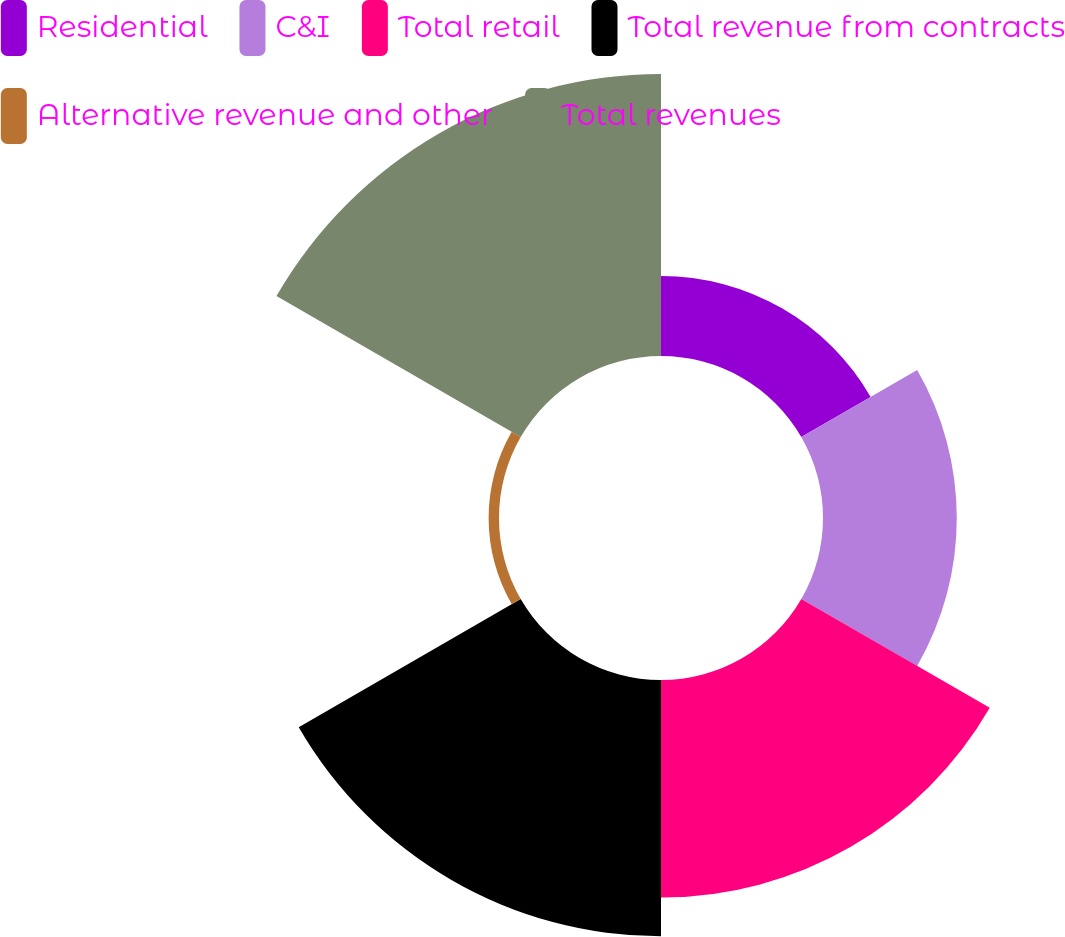Convert chart. <chart><loc_0><loc_0><loc_500><loc_500><pie_chart><fcel>Residential<fcel>C&I<fcel>Total retail<fcel>Total revenue from contracts<fcel>Alternative revenue and other<fcel>Total revenues<nl><fcel>8.17%<fcel>13.65%<fcel>22.2%<fcel>26.15%<fcel>1.06%<fcel>28.77%<nl></chart> 